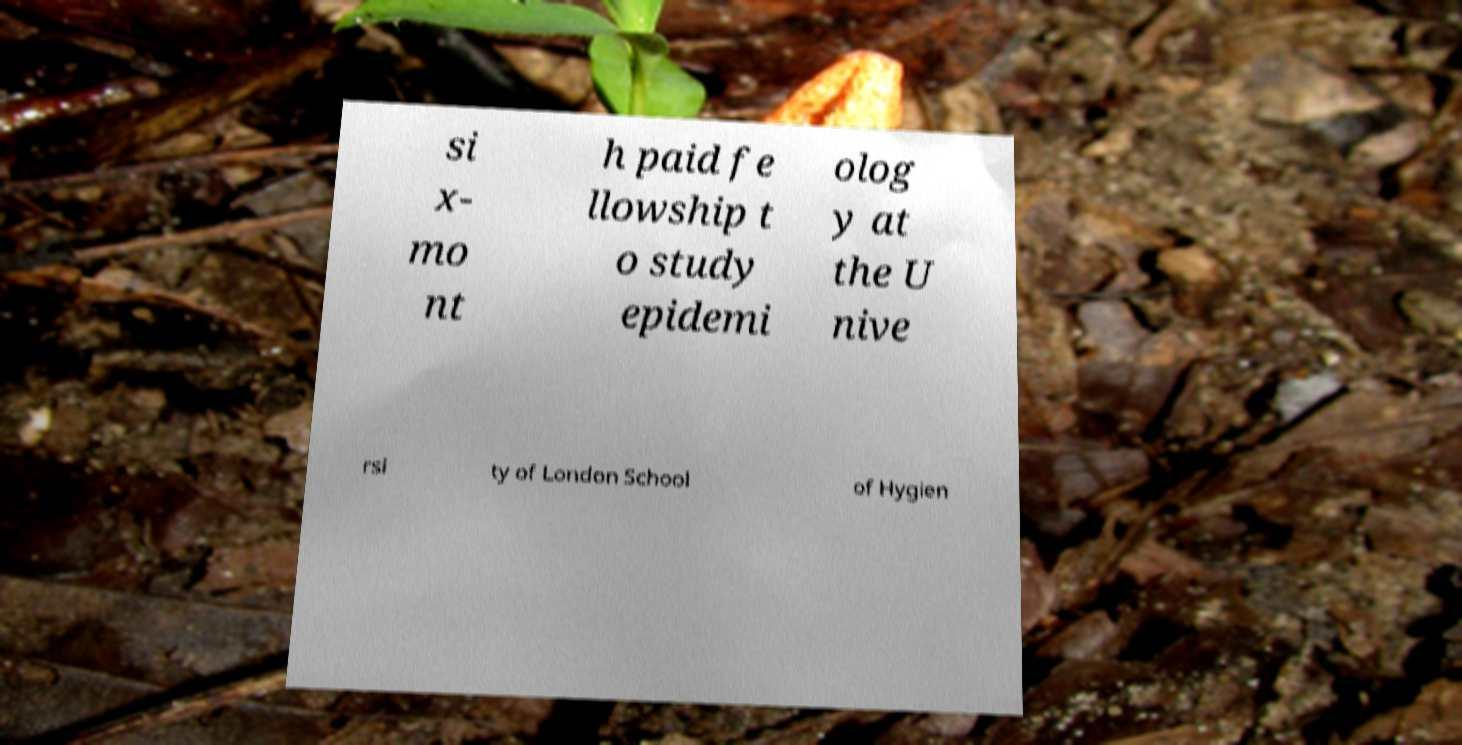Please read and relay the text visible in this image. What does it say? si x- mo nt h paid fe llowship t o study epidemi olog y at the U nive rsi ty of London School of Hygien 